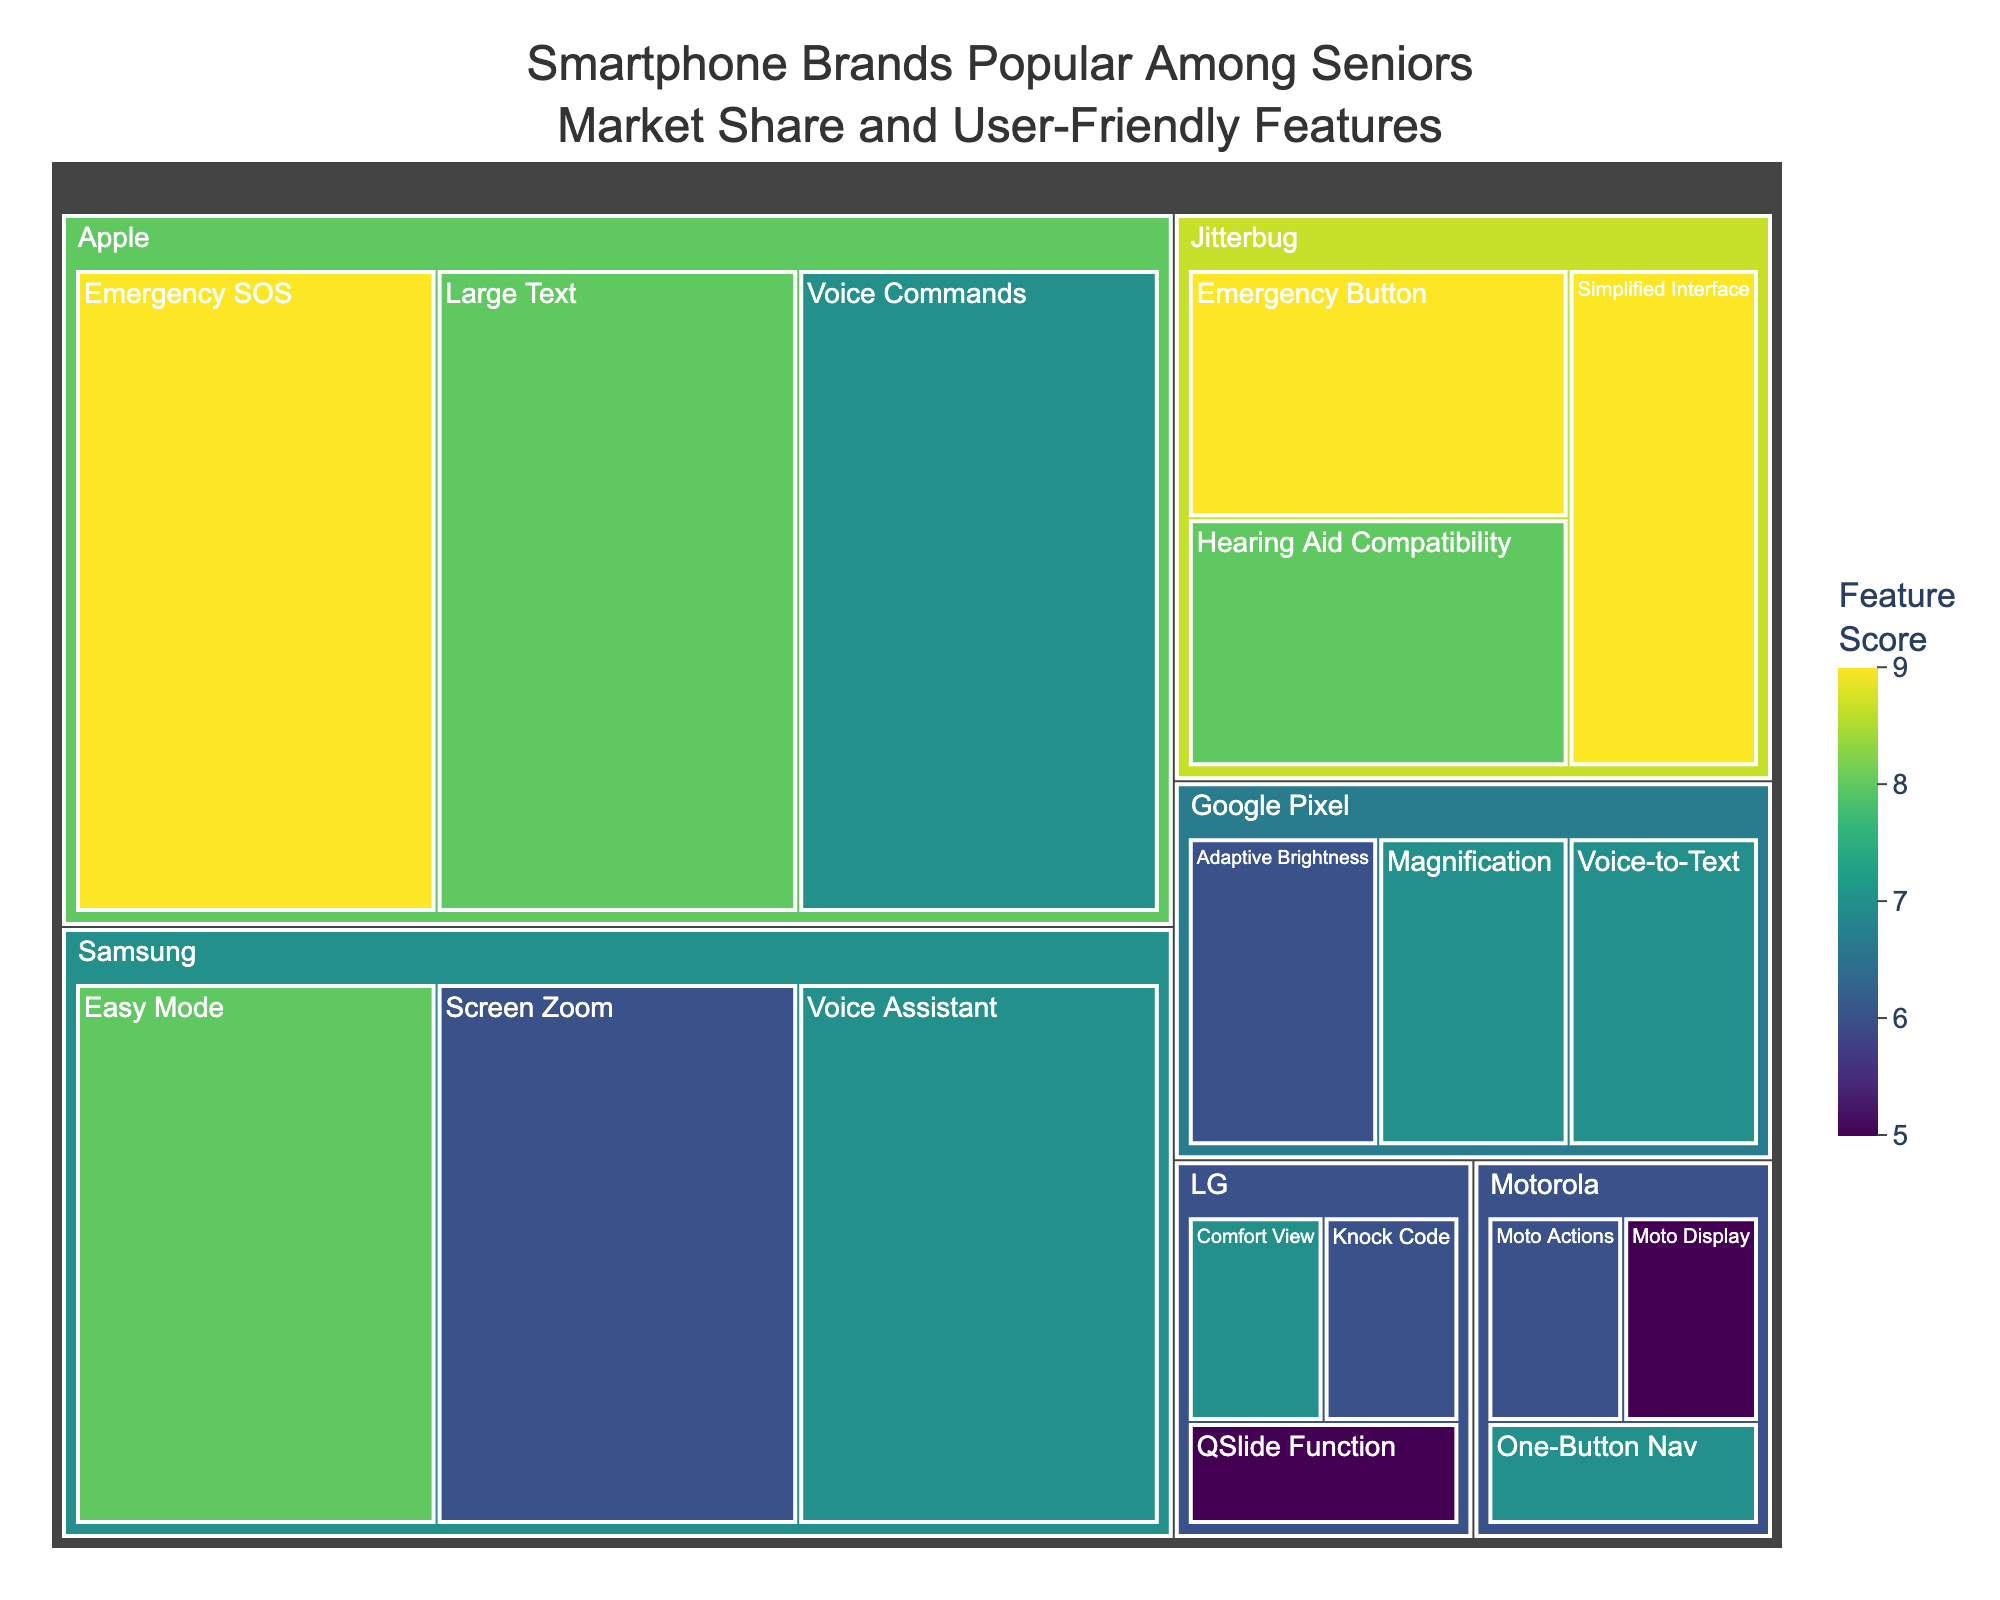What is the total market share of Apple among seniors? The total market share of Apple can be found by looking at the size of the section labeled "Apple" in the treemap, which is 35%.
Answer: 35% Which feature of Jitterbug has the highest score? By looking at the Jitterbug section and comparing the scores for each feature, the feature with the highest score is the "Emergency Button" with a score of 9.
Answer: Emergency Button What is the total market share of brands other than Apple and Samsung? Subtract the combined market share of Apple (35%) and Samsung (30%) from 100%. This results in 100% - 35% - 30% = 35%.
Answer: 35% Which brand has a feature with the lowest score, and what is that score? By comparing all features, the brand with the lowest score is LG, with its "QSlide Function" having a score of 5.
Answer: LG with QSlide Function having a score of 5 How does the total market share of Jitterbug compare to Google Pixel? By comparing the sections labeled Jitterbug and Google Pixel, Jitterbug has a total market share of 15% which is greater than Google Pixel's 10%.
Answer: Jitterbug's market share is greater than Google Pixel's market share Which feature of Apple has the highest score? By looking at the Apple section in the treemap, the feature with the highest score is "Emergency SOS" with a score of 9.
Answer: Emergency SOS Which brand provides the most user-friendly feature in terms of score? By observing all features and their scores, the user-friendly features with the highest score (9) are offered by Apple (Emergency SOS) and Jitterbug (Simplified Interface and Emergency Button).
Answer: Apple and Jitterbug What is the average score of features offered by Motorola? Motorola has "Moto Actions" (6), "Moto Display" (5), and "One-Button Nav" (7). The average score is calculated as (6 + 5 + 7) / 3 = 6.
Answer: 6 